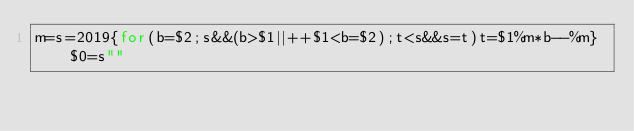<code> <loc_0><loc_0><loc_500><loc_500><_Awk_>m=s=2019{for(b=$2;s&&(b>$1||++$1<b=$2);t<s&&s=t)t=$1%m*b--%m}$0=s""</code> 